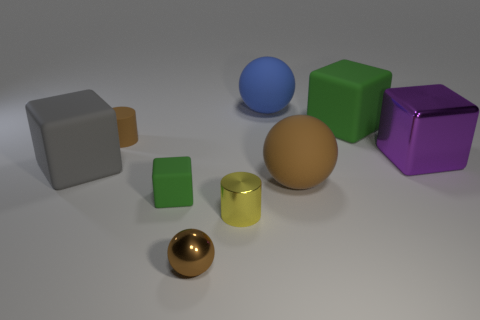What is the color of the other cylinder that is the same size as the shiny cylinder?
Your answer should be very brief. Brown. There is a metallic cube; is its color the same as the small cylinder that is to the left of the shiny cylinder?
Ensure brevity in your answer.  No. What is the color of the small rubber cube?
Offer a very short reply. Green. What is the material of the brown sphere to the right of the small sphere?
Your response must be concise. Rubber. What is the size of the other rubber thing that is the same shape as the large blue rubber object?
Your answer should be very brief. Large. Is the number of rubber cubes behind the large metal cube less than the number of blue spheres?
Make the answer very short. No. Are any big cyan matte things visible?
Provide a succinct answer. No. What color is the tiny rubber thing that is the same shape as the big purple shiny thing?
Make the answer very short. Green. There is a rubber sphere right of the large blue rubber object; is it the same color as the shiny ball?
Make the answer very short. Yes. Does the metallic ball have the same size as the purple object?
Offer a terse response. No. 